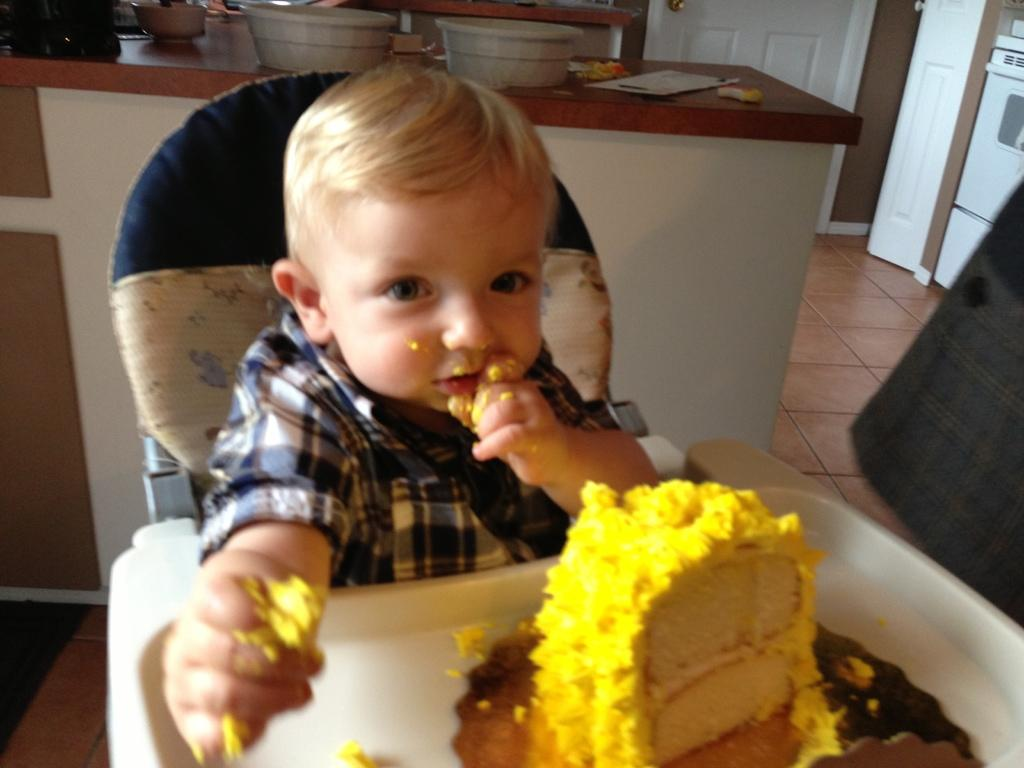What is the boy in the image doing? The boy is playing with a pastry in the image. Where is the boy seated? The provided facts do not specify where the boy is seated. What can be seen on the countertop in the image? There are vessels on the countertop in the image. What type of arithmetic problem is the boy solving on the flesh in the image? There is no mention of arithmetic problems or flesh in the image; the boy is playing with a pastry on a countertop. 